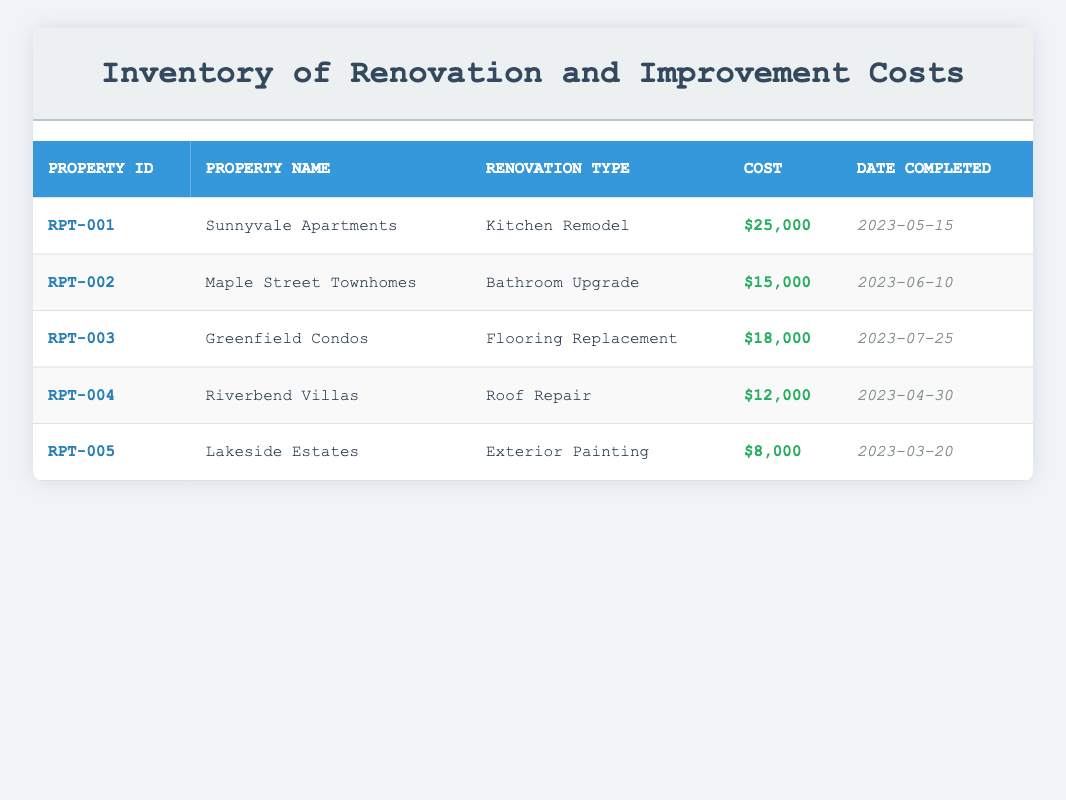What is the cost of the renovation for Sunnyvale Apartments? The cost of the renovation for Sunnyvale Apartments is listed directly in the table under the Cost column, which states $25,000.
Answer: $25,000 Which property had the least amount spent on renovations? By examining the Cost column, Lakeside Estates, with a cost of $8,000, has the lowest amount spent compared to the other properties.
Answer: Lakeside Estates What is the total cost of renovations for all properties? To find the total cost, we sum the individual costs: $25,000 + $15,000 + $18,000 + $12,000 + $8,000 = $78,000.
Answer: $78,000 Did Riverbend Villas undergo a Kitchen Remodel? Looking at the Renovation Type column, Riverbend Villas had a Roof Repair, not a Kitchen Remodel.
Answer: No How many renovations were completed between May and July 2023? We will check the Date Completed column: Renovations for Sunnyvale Apartments, Maple Street Townhomes, and Greenfield Condos fall within this range (May 15 to July 25), totaling three renovations.
Answer: 3 What is the average cost of renovations for all properties? First, we sum the total costs as $78,000. Then, we calculate the average by dividing by the number of properties (5): $78,000 / 5 = $15,600.
Answer: $15,600 Which property had its renovations completed first? Checking the Date Completed column, Lakeside Estates had its renovations completed on March 20, 2023, making it the earliest completion.
Answer: Lakeside Estates Is the cost of the Bathroom Upgrade greater than $12,000? Referring to the Cost column, the Bathroom Upgrade cost is listed as $15,000, which is indeed greater than $12,000.
Answer: Yes Identify the renovation type for Greenfield Condos. The Renovation Type column indicates that Greenfield Condos underwent a Flooring Replacement.
Answer: Flooring Replacement 